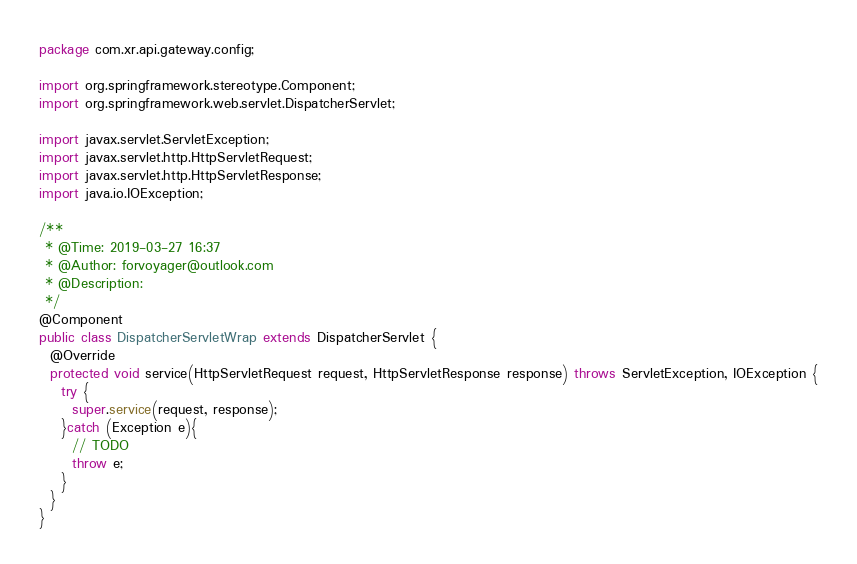Convert code to text. <code><loc_0><loc_0><loc_500><loc_500><_Java_>package com.xr.api.gateway.config;

import org.springframework.stereotype.Component;
import org.springframework.web.servlet.DispatcherServlet;

import javax.servlet.ServletException;
import javax.servlet.http.HttpServletRequest;
import javax.servlet.http.HttpServletResponse;
import java.io.IOException;

/**
 * @Time: 2019-03-27 16:37
 * @Author: forvoyager@outlook.com
 * @Description:
 */
@Component
public class DispatcherServletWrap extends DispatcherServlet {
  @Override
  protected void service(HttpServletRequest request, HttpServletResponse response) throws ServletException, IOException {
    try {
      super.service(request, response);
    }catch (Exception e){
      // TODO
      throw e;
    }
  }
}
</code> 